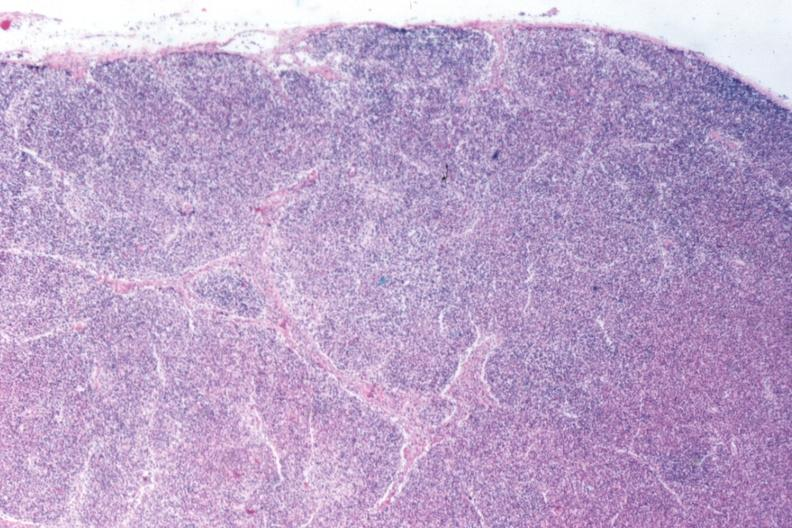does this image show that total effacement case appears to have changed into a blast crisis?
Answer the question using a single word or phrase. Yes 